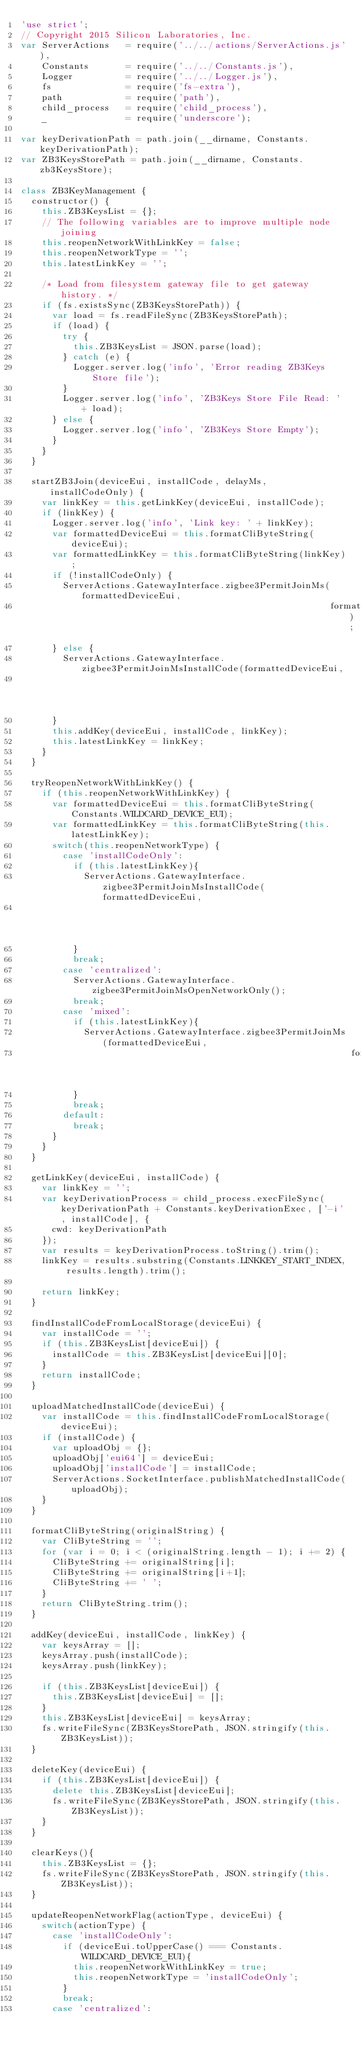<code> <loc_0><loc_0><loc_500><loc_500><_JavaScript_>'use strict';
// Copyright 2015 Silicon Laboratories, Inc.
var ServerActions   = require('../../actions/ServerActions.js'),
    Constants       = require('../../Constants.js'),
    Logger          = require('../../Logger.js'),
    fs              = require('fs-extra'),
    path            = require('path'),
    child_process   = require('child_process'),
    _               = require('underscore');

var keyDerivationPath = path.join(__dirname, Constants.keyDerivationPath);
var ZB3KeysStorePath = path.join(__dirname, Constants.zb3KeysStore);

class ZB3KeyManagement {
  constructor() {
    this.ZB3KeysList = {};
    // The following variables are to improve multiple node joining
    this.reopenNetworkWithLinkKey = false;
    this.reopenNetworkType = '';
    this.latestLinkKey = '';

    /* Load from filesystem gateway file to get gateway history. */
    if (fs.existsSync(ZB3KeysStorePath)) {
      var load = fs.readFileSync(ZB3KeysStorePath);
      if (load) {
        try {
          this.ZB3KeysList = JSON.parse(load);
        } catch (e) {
          Logger.server.log('info', 'Error reading ZB3Keys Store file');
        }
        Logger.server.log('info', 'ZB3Keys Store File Read: ' + load);
      } else {
        Logger.server.log('info', 'ZB3Keys Store Empty');
      }
    }
  }

  startZB3Join(deviceEui, installCode, delayMs, installCodeOnly) {
    var linkKey = this.getLinkKey(deviceEui, installCode);
    if (linkKey) {
      Logger.server.log('info', 'Link key: ' + linkKey);
      var formattedDeviceEui = this.formatCliByteString(deviceEui);
      var formattedLinkKey = this.formatCliByteString(linkKey);
      if (!installCodeOnly) {
        ServerActions.GatewayInterface.zigbee3PermitJoinMs(formattedDeviceEui,
                                                           formattedLinkKey);
      } else {
        ServerActions.GatewayInterface.zigbee3PermitJoinMsInstallCode(formattedDeviceEui,
                                                                      formattedLinkKey);
      }
      this.addKey(deviceEui, installCode, linkKey);
      this.latestLinkKey = linkKey;
    }
  }

  tryReopenNetworkWithLinkKey() {
    if (this.reopenNetworkWithLinkKey) {
      var formattedDeviceEui = this.formatCliByteString(Constants.WILDCARD_DEVICE_EUI);
      var formattedLinkKey = this.formatCliByteString(this.latestLinkKey);
      switch(this.reopenNetworkType) {
        case 'installCodeOnly':
          if (this.latestLinkKey){
            ServerActions.GatewayInterface.zigbee3PermitJoinMsInstallCode(formattedDeviceEui,
                                                                          formattedLinkKey);
          }
          break;
        case 'centralized':
          ServerActions.GatewayInterface.zigbee3PermitJoinMsOpenNetworkOnly();
          break;
        case 'mixed':
          if (this.latestLinkKey){
            ServerActions.GatewayInterface.zigbee3PermitJoinMs(formattedDeviceEui,
                                                               formattedLinkKey);
          }
          break;
        default:
          break;
      }
    }
  }

  getLinkKey(deviceEui, installCode) {
    var linkKey = '';
    var keyDerivationProcess = child_process.execFileSync(keyDerivationPath + Constants.keyDerivationExec, ['-i', installCode], {
      cwd: keyDerivationPath
    });
    var results = keyDerivationProcess.toString().trim();
    linkKey = results.substring(Constants.LINKKEY_START_INDEX, results.length).trim();

    return linkKey;
  }

  findInstallCodeFromLocalStorage(deviceEui) {
    var installCode = '';
    if (this.ZB3KeysList[deviceEui]) {
      installCode = this.ZB3KeysList[deviceEui][0];
    }
    return installCode;
  }

  uploadMatchedInstallCode(deviceEui) {
    var installCode = this.findInstallCodeFromLocalStorage(deviceEui);
    if (installCode) {
      var uploadObj = {};
      uploadObj['eui64'] = deviceEui;
      uploadObj['installCode'] = installCode;
      ServerActions.SocketInterface.publishMatchedInstallCode(uploadObj);
    }
  }

  formatCliByteString(originalString) {
    var CliByteString = '';
    for (var i = 0; i < (originalString.length - 1); i += 2) {
      CliByteString += originalString[i];
      CliByteString += originalString[i+1];
      CliByteString += ' ';
    }
    return CliByteString.trim();
  }

  addKey(deviceEui, installCode, linkKey) {
    var keysArray = [];
    keysArray.push(installCode);
    keysArray.push(linkKey);

    if (this.ZB3KeysList[deviceEui]) {
      this.ZB3KeysList[deviceEui] = [];
    }
    this.ZB3KeysList[deviceEui] = keysArray;
    fs.writeFileSync(ZB3KeysStorePath, JSON.stringify(this.ZB3KeysList));
  }

  deleteKey(deviceEui) {
    if (this.ZB3KeysList[deviceEui]) {
      delete this.ZB3KeysList[deviceEui];
      fs.writeFileSync(ZB3KeysStorePath, JSON.stringify(this.ZB3KeysList));
    }
  }

  clearKeys(){
    this.ZB3KeysList = {};
    fs.writeFileSync(ZB3KeysStorePath, JSON.stringify(this.ZB3KeysList));
  }

  updateReopenNetworkFlag(actionType, deviceEui) {
    switch(actionType) {
      case 'installCodeOnly':
        if (deviceEui.toUpperCase() === Constants.WILDCARD_DEVICE_EUI){
          this.reopenNetworkWithLinkKey = true;
          this.reopenNetworkType = 'installCodeOnly';
        }
        break;
      case 'centralized':</code> 